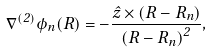<formula> <loc_0><loc_0><loc_500><loc_500>\nabla ^ { ( 2 ) } \phi _ { n } ( R ) = - \frac { \hat { z } \times \left ( { R } - { R } _ { n } \right ) } { \left ( { R } - { R } _ { n } \right ) ^ { 2 } } ,</formula> 